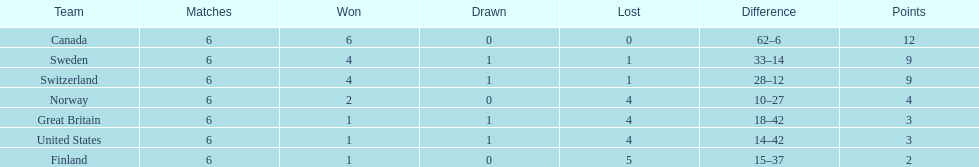How many teams won only 1 match? 3. 